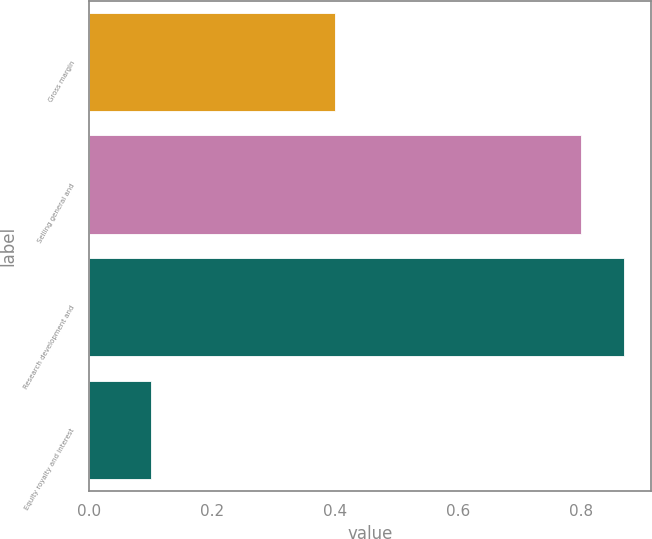Convert chart. <chart><loc_0><loc_0><loc_500><loc_500><bar_chart><fcel>Gross margin<fcel>Selling general and<fcel>Research development and<fcel>Equity royalty and interest<nl><fcel>0.4<fcel>0.8<fcel>0.87<fcel>0.1<nl></chart> 